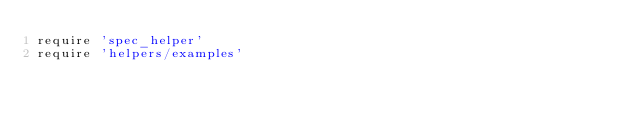Convert code to text. <code><loc_0><loc_0><loc_500><loc_500><_Ruby_>require 'spec_helper'
require 'helpers/examples'
</code> 